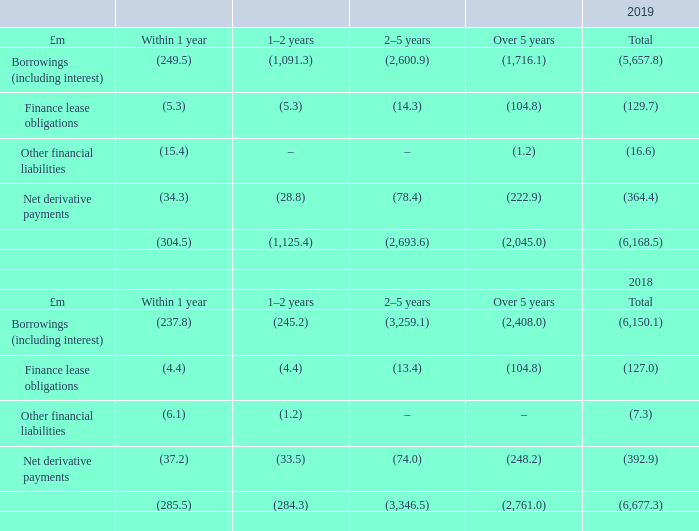Liquidity risk
Liquidity risk is managed to enable the Group to meet future payment obligations when financial liabilities fall due. Liquidity analysis is conducted to determine that sufficient headroom is available to meet the Group’s operational requirements and committed investments. The Group treasury policy aims to meet this objective by maintaining adequate cash, marketable securities and committed facilities. Undrawn borrowing facilities are detailed in note 23. The Group’s policy is to seek to optimise its exposure to liquidity risk by balancing its exposure to interest rate risk and to refinancing risk. In effect the Group seeks to borrow for as long as possible at the lowest acceptable cost.
Group policy is to maintain a weighted average debt maturity of over five years. At 31 December 2019, the maturity profile of Group debt showed an average maturity of five years (2018: six years). The Group regularly reviews the maturity profile of its borrowings and seeks to avoid concentration of maturities through the regular replacement of facilities and by arranging a selection of maturity dates. Refinancing risk may be reduced by doing so prior to the contracted maturity date. The change in valuation of an asset used as security for a debt facility may impact the Group’s ability to refinance that debt facility at the same quantum as currently outstanding.
The Group does not use supplier financing arrangements to manage liquidity risk.
The tables below set out the maturity analysis of the Group’s financial liabilities based on the undiscounted contractual obligations to make payments of interest and to repay principal. Where interest payment obligations are based on a floating rate, the rates used are those implied by the par yield curve for the relevant currency. Where payment obligations are in foreign currencies, the spot exchange rate at the balance sheet date is used.
What is the average maturity of the Group debt in 2019? Five years. What is the average maturity of the Group debt in 2018? Six years. Why is liquidity analysis conducted? To determine that sufficient headroom is available to meet the group’s operational requirements and committed investments. What is the percentage change in the borrowings (including interest) that matures within 1 year from 2018 to 2019?
Answer scale should be: percent. (249.5-237.8)/237.8
Answer: 4.92. What is the percentage of borrowings (including interest) that matures over 5 years in the total borrowings in 2019?
Answer scale should be: percent. 1,716.1/5,657.8
Answer: 30.33. What is the percentage change in the total finance lease obligations from 2018 to 2019?
Answer scale should be: percent. (129.7-127.0)/127.0
Answer: 2.13. 